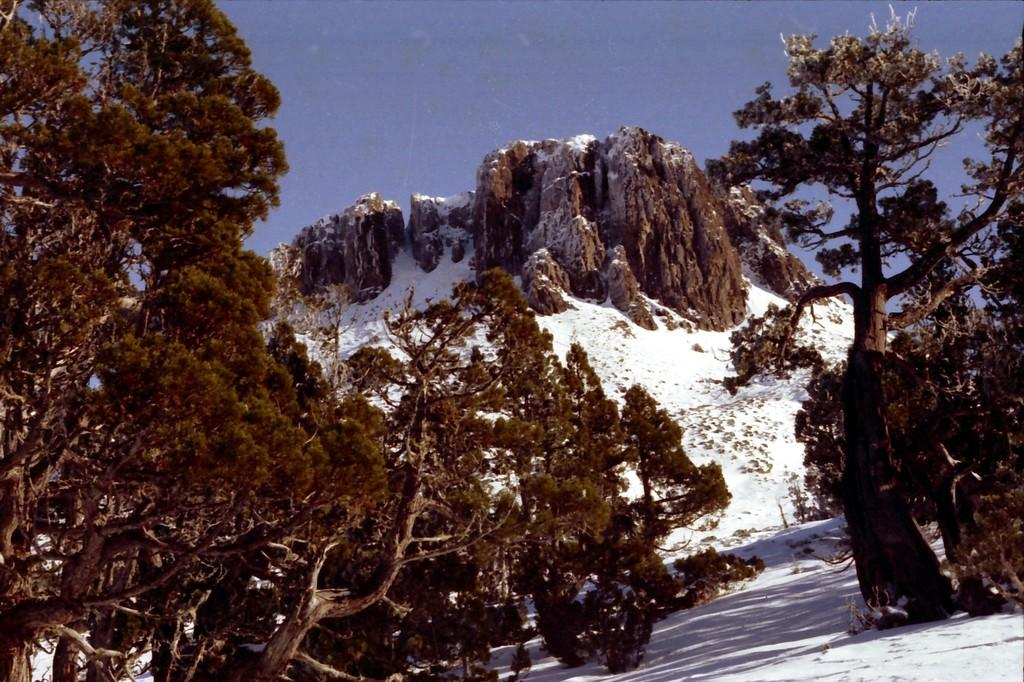What type of vegetation can be seen in the image? There are trees in the image. What geographical feature is present in the image? There is a mountain in the image. What is the condition of the mountain in the image? There is snow on the mountain. What is visible at the top of the image? The sky is visible at the top of the image. What is the condition of the ground in the image? There is snow at the bottom of the image. Can you tell me how many wrenches are lying on the ground in the image? There are no wrenches present in the image; it features trees, a mountain, snow, and the sky. What type of creature is shown interacting with the snow on the ground in the image? There is no creature shown interacting with the snow on the ground in the image. 